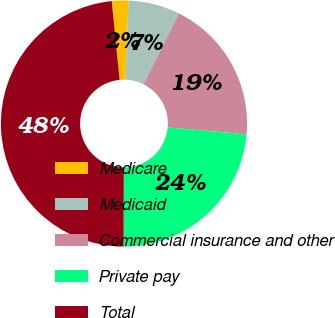Convert chart to OTSL. <chart><loc_0><loc_0><loc_500><loc_500><pie_chart><fcel>Medicare<fcel>Medicaid<fcel>Commercial insurance and other<fcel>Private pay<fcel>Total<nl><fcel>2.17%<fcel>6.79%<fcel>19.03%<fcel>23.65%<fcel>48.36%<nl></chart> 